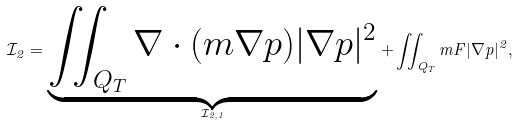Convert formula to latex. <formula><loc_0><loc_0><loc_500><loc_500>\mathcal { I } _ { 2 } = \underbrace { \iint _ { Q _ { T } } \nabla \cdot ( m \nabla p ) | \nabla p | ^ { 2 } } _ { \mathcal { I } _ { 2 , 1 } } + \iint _ { Q _ { T } } m F | \nabla p | ^ { 2 } ,</formula> 